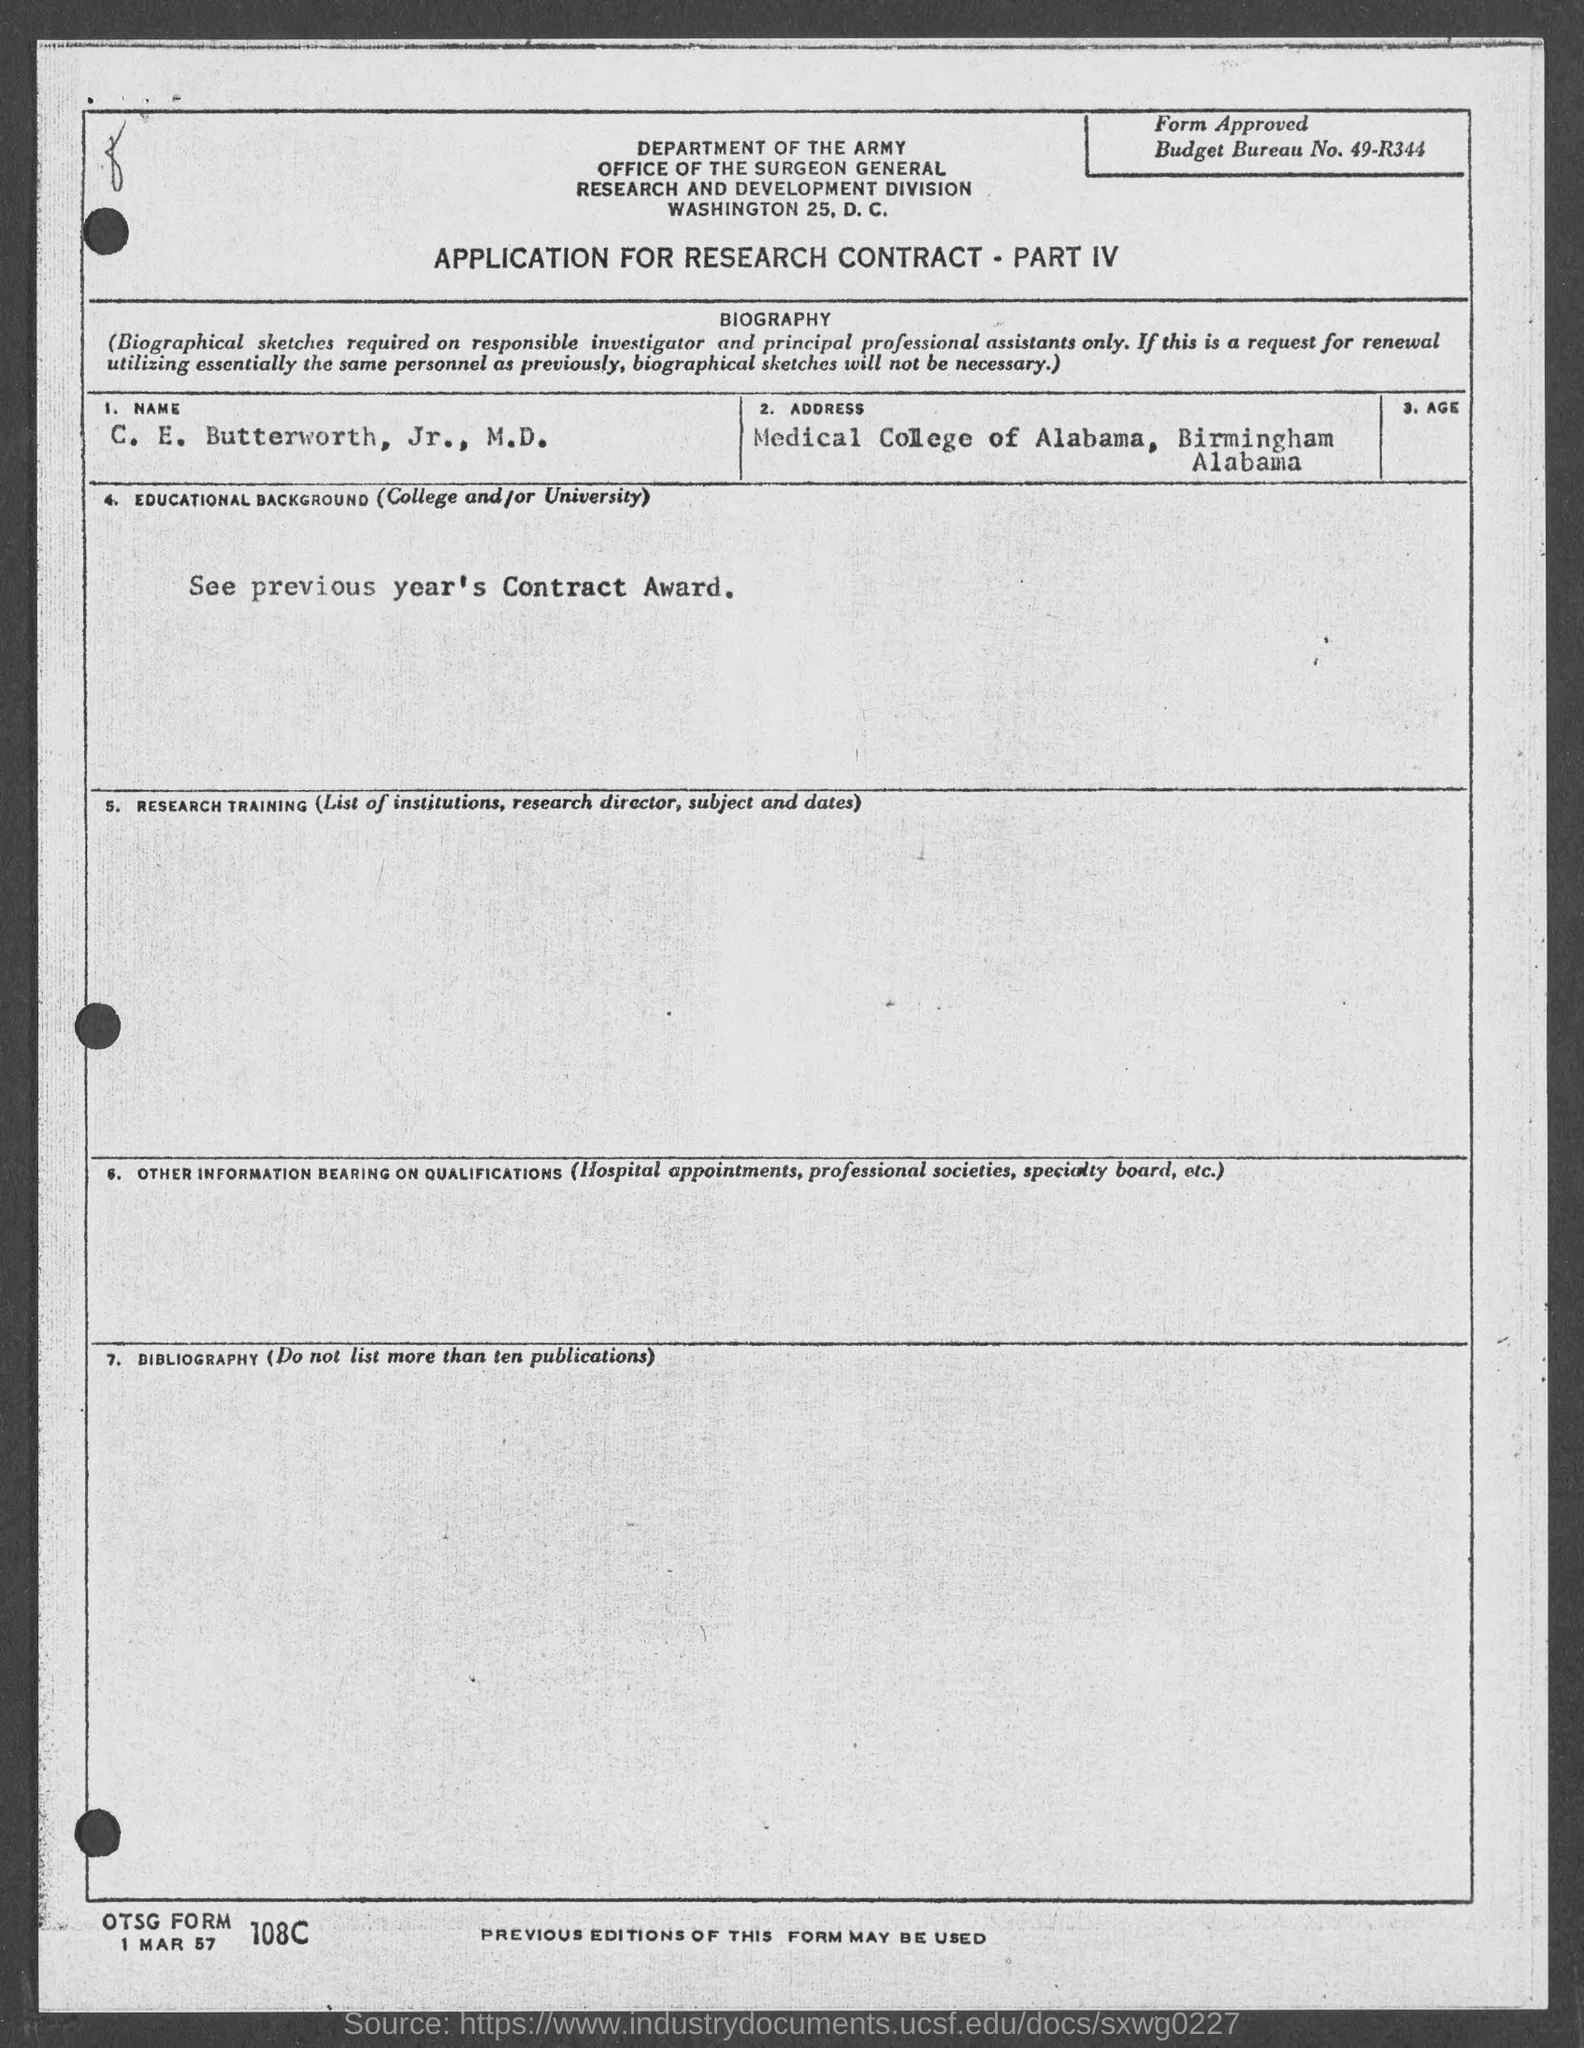What is the budget bureau no.?
Ensure brevity in your answer.  49-r344. What is the name of person in the form?
Provide a succinct answer. C. e. butterworth, jr., m.d. In which state is medical college of alabama  located ?
Your response must be concise. Alabama. 